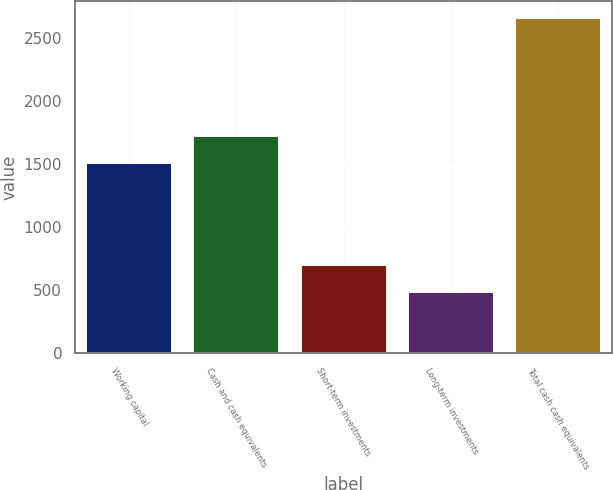<chart> <loc_0><loc_0><loc_500><loc_500><bar_chart><fcel>Working capital<fcel>Cash and cash equivalents<fcel>Short-term investments<fcel>Long-term investments<fcel>Total cash cash equivalents<nl><fcel>1503.2<fcel>1720.72<fcel>701.02<fcel>483.5<fcel>2658.7<nl></chart> 